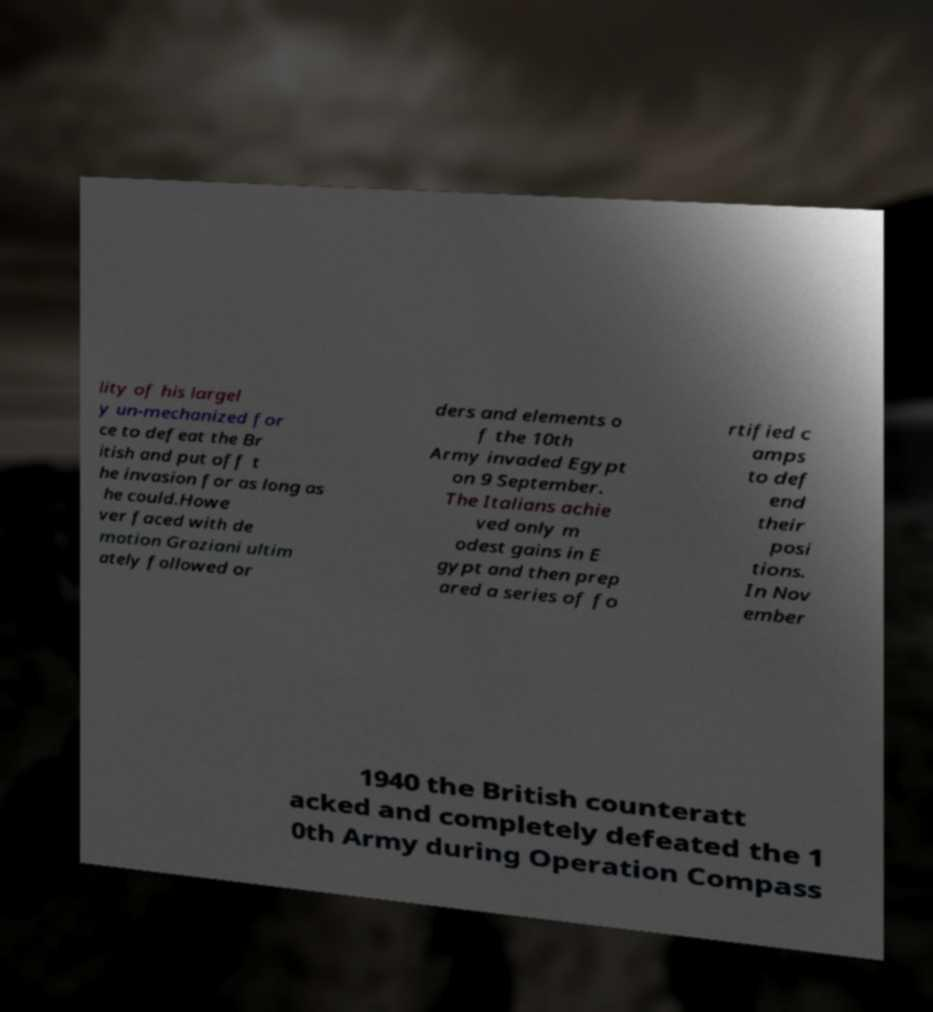Please read and relay the text visible in this image. What does it say? lity of his largel y un-mechanized for ce to defeat the Br itish and put off t he invasion for as long as he could.Howe ver faced with de motion Graziani ultim ately followed or ders and elements o f the 10th Army invaded Egypt on 9 September. The Italians achie ved only m odest gains in E gypt and then prep ared a series of fo rtified c amps to def end their posi tions. In Nov ember 1940 the British counteratt acked and completely defeated the 1 0th Army during Operation Compass 